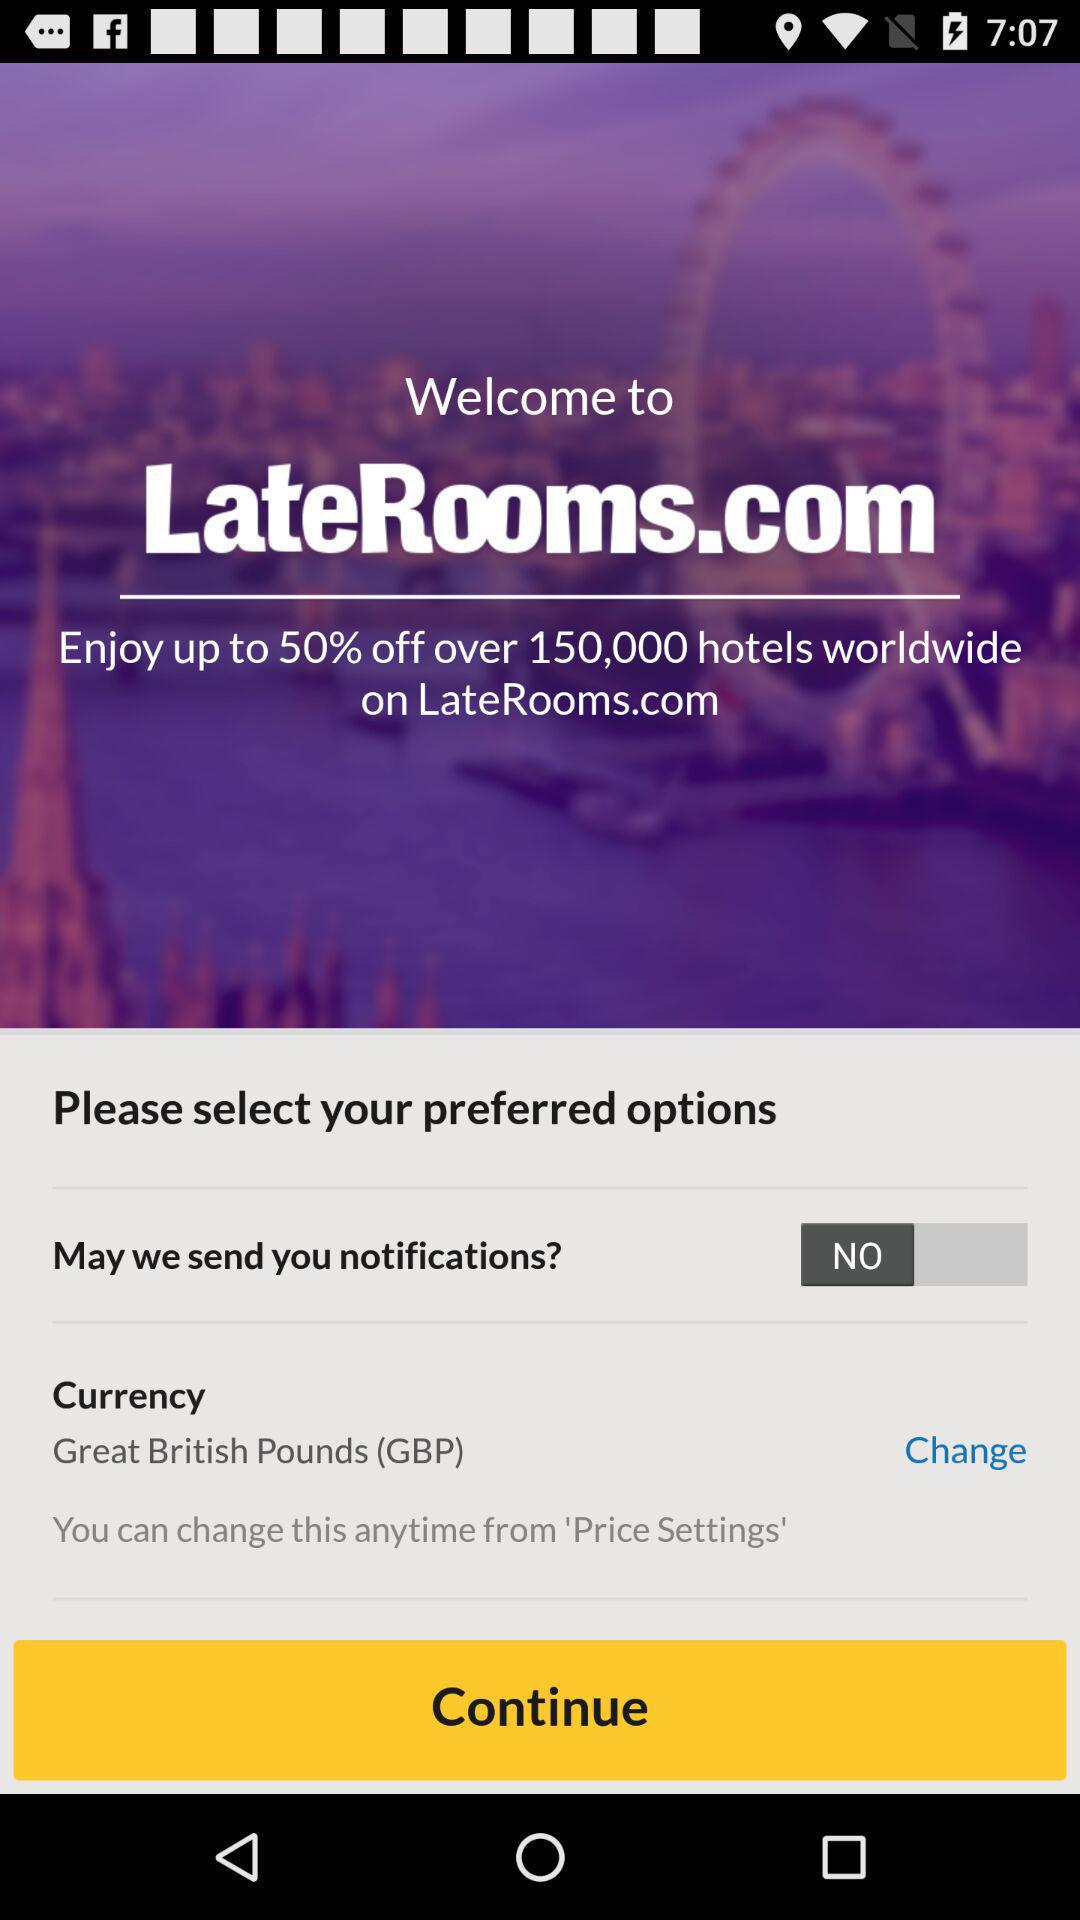How much of a discount will LateRooms.com provide on hotels? LateRooms.com will provide up to 50% off on hotels. 